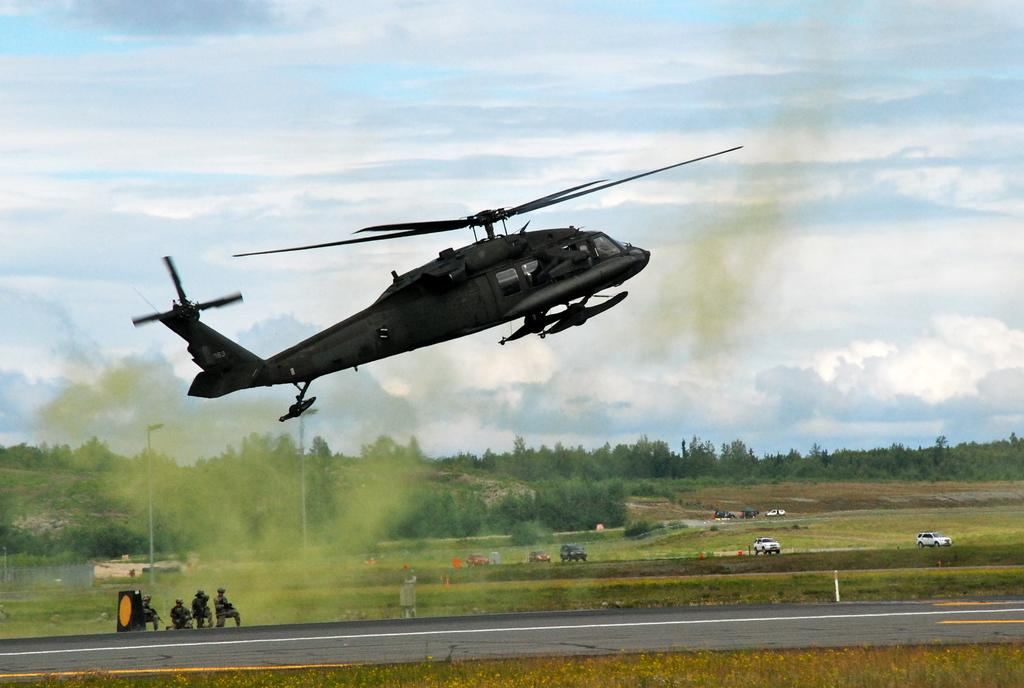What type of vegetation is visible in the image? There is grass in the image. What type of man-made structure can be seen in the image? There is a road in the image. What type of natural feature is present in the image? There are trees in the image. Who or what is present in the image? There are people in the image. What type of lighting is present in the image? There are street lights in the image. What can be seen in the sky in the image? There are clouds in the sky. What type of transportation is visible in the image? There is an airplane in the image. What type of meeting is taking place in the image? There is no meeting present in the image. What type of material is burning in the image? There is no material burning in the image. 